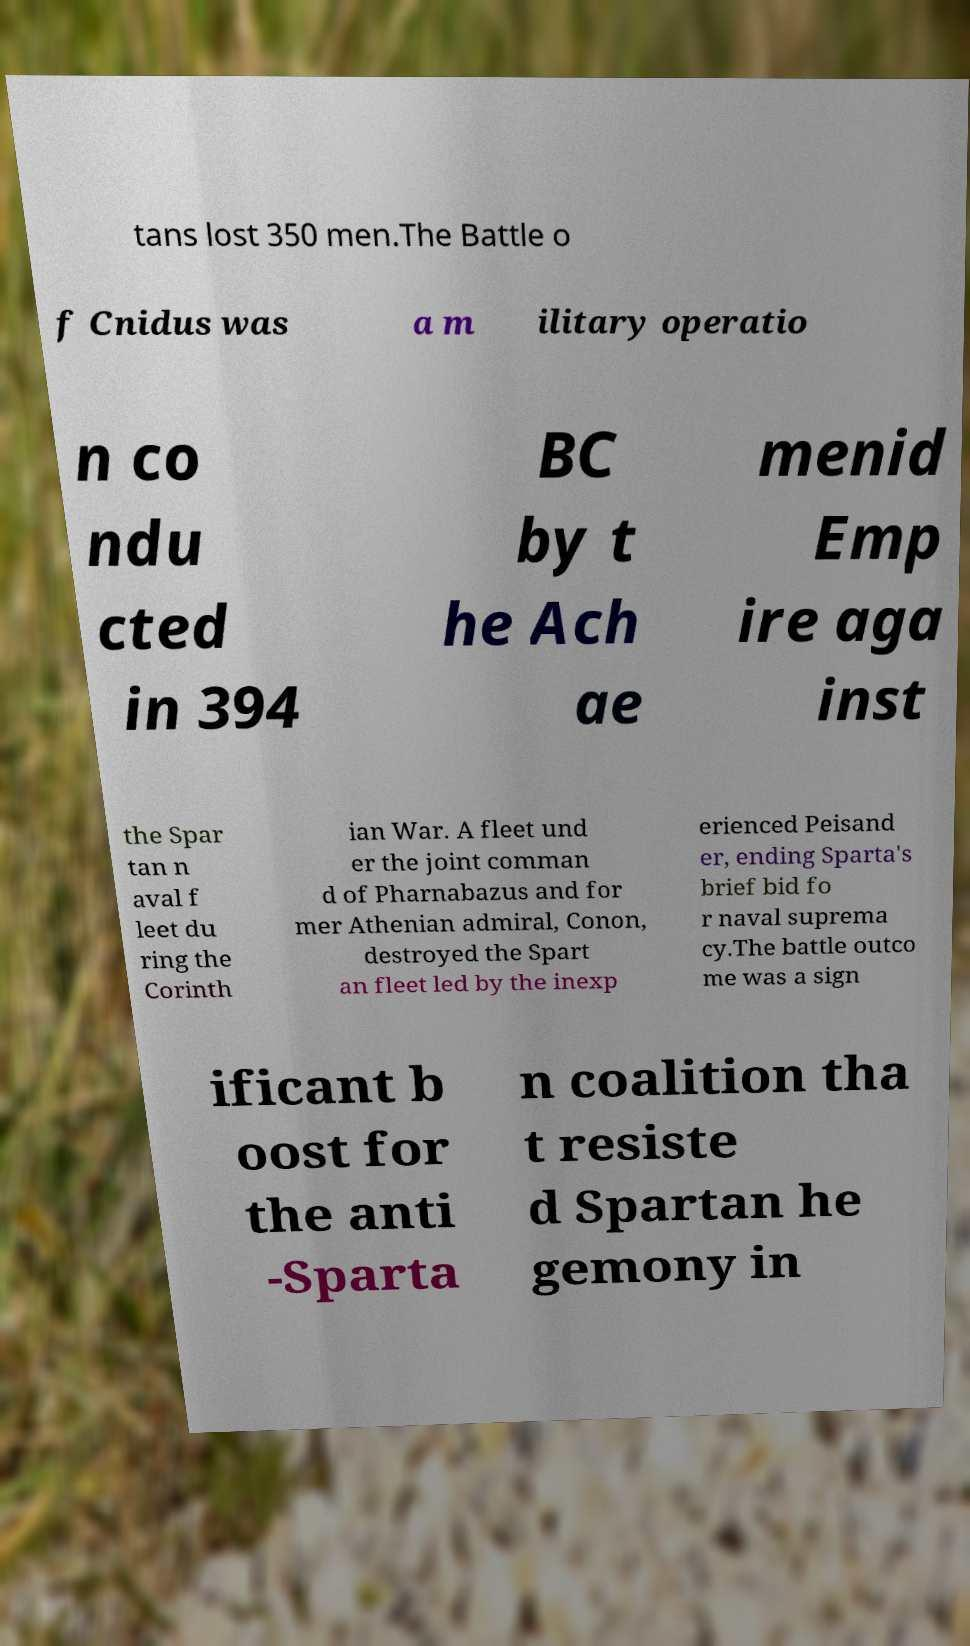There's text embedded in this image that I need extracted. Can you transcribe it verbatim? tans lost 350 men.The Battle o f Cnidus was a m ilitary operatio n co ndu cted in 394 BC by t he Ach ae menid Emp ire aga inst the Spar tan n aval f leet du ring the Corinth ian War. A fleet und er the joint comman d of Pharnabazus and for mer Athenian admiral, Conon, destroyed the Spart an fleet led by the inexp erienced Peisand er, ending Sparta's brief bid fo r naval suprema cy.The battle outco me was a sign ificant b oost for the anti -Sparta n coalition tha t resiste d Spartan he gemony in 